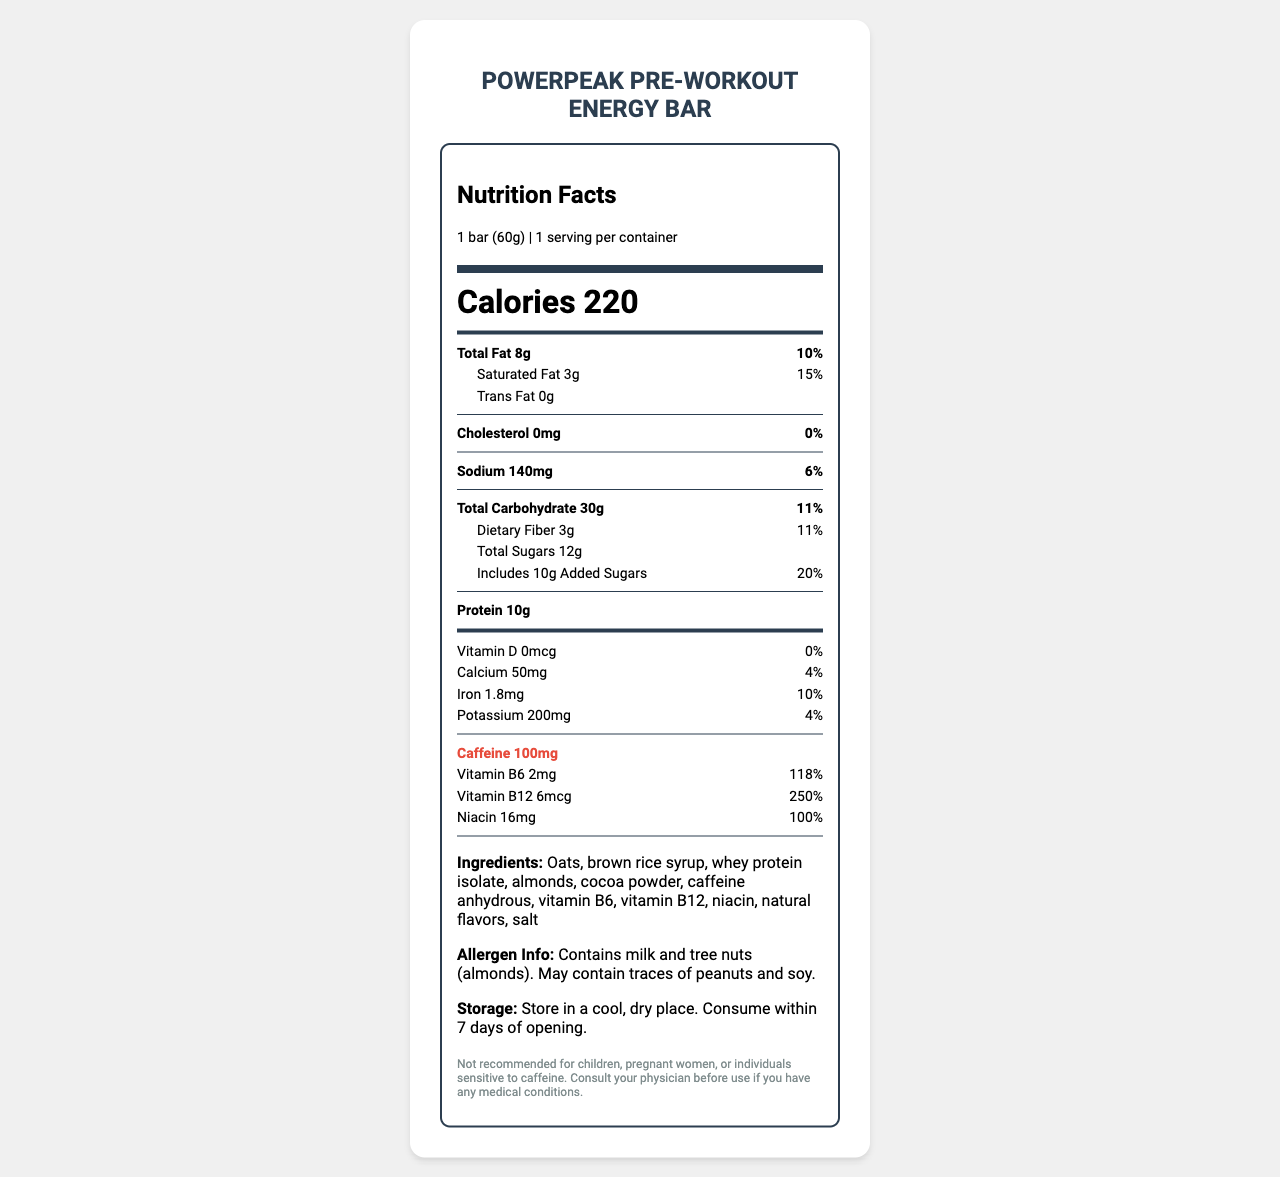what is the serving size of the PowerPeak Pre-Workout Energy Bar? The serving size is mentioned at the top of the nutrition label as "1 bar (60g)".
Answer: 1 bar (60g) how many calories are there in one serving of the PowerPeak Pre-Workout Energy Bar? The number of calories per serving is prominently displayed in large font on the label as "Calories 220".
Answer: 220 what is the amount of total fat in one serving? Total fat content is listed under the nutrition information as "Total Fat 8g".
Answer: 8g what is the daily value percentage of saturated fat in this energy bar? The daily value percentage for saturated fat is mentioned as "15%" next to the "Saturated Fat 3g".
Answer: 15% what amount of vitamin B6 does this bar contain? The amount of vitamin B6 is mentioned in the nutrition facts section as "Vitamin B6 2mg".
Answer: 2mg which of the following is the main source of protein in this energy bar? A. Almonds B. Whey protein isolate C. Oats D. Brown rice syrup The ingredients list indicates that whey protein isolate is likely the main source of protein.
Answer: B how much caffeine is in this energy bar? A. 50mg B. 80mg C. 100mg D. 150mg The nutrition label states that the bar contains "Caffeine 100mg".
Answer: C does this product contain any dietary fiber? The nutrition label shows "Dietary Fiber 3g", which confirms the presence of dietary fiber.
Answer: Yes is this energy bar recommended for children? The disclaimer at the bottom of the label specifically states, "Not recommended for children".
Answer: No how long can this energy bar be consumed after opening? The storage instructions state: "Consume within 7 days of opening".
Answer: 7 days how much iron is in this energy bar? The nutrition label shows "Iron 1.8mg" in the vitamin and mineral section.
Answer: 1.8mg is the product suitable for vegans? The document does not provide enough information about the suitability for vegans. It contains whey protein isolate, which is derived from milk, but it doesn't confirm if other ingredients comply with vegan standards.
Answer: Cannot be determined 